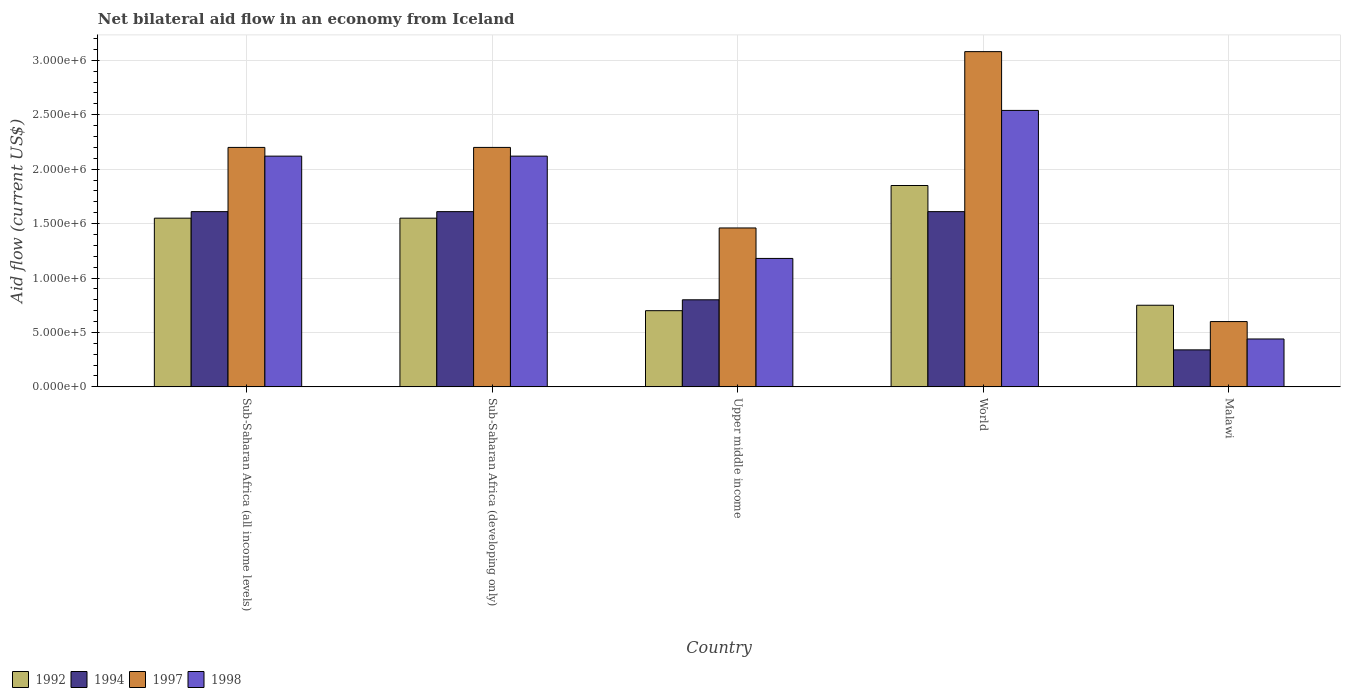How many groups of bars are there?
Provide a succinct answer. 5. Are the number of bars on each tick of the X-axis equal?
Your response must be concise. Yes. What is the label of the 3rd group of bars from the left?
Ensure brevity in your answer.  Upper middle income. What is the net bilateral aid flow in 1994 in Sub-Saharan Africa (developing only)?
Provide a succinct answer. 1.61e+06. Across all countries, what is the maximum net bilateral aid flow in 1997?
Keep it short and to the point. 3.08e+06. In which country was the net bilateral aid flow in 1998 minimum?
Give a very brief answer. Malawi. What is the total net bilateral aid flow in 1994 in the graph?
Your answer should be very brief. 5.97e+06. What is the difference between the net bilateral aid flow in 1994 in Malawi and that in Upper middle income?
Provide a succinct answer. -4.60e+05. What is the difference between the net bilateral aid flow in 1994 in Sub-Saharan Africa (all income levels) and the net bilateral aid flow in 1992 in Upper middle income?
Ensure brevity in your answer.  9.10e+05. What is the average net bilateral aid flow in 1992 per country?
Your answer should be very brief. 1.28e+06. What is the difference between the net bilateral aid flow of/in 1997 and net bilateral aid flow of/in 1994 in Malawi?
Your response must be concise. 2.60e+05. What is the ratio of the net bilateral aid flow in 1998 in Malawi to that in Sub-Saharan Africa (developing only)?
Ensure brevity in your answer.  0.21. What is the difference between the highest and the second highest net bilateral aid flow in 1992?
Provide a short and direct response. 3.00e+05. What is the difference between the highest and the lowest net bilateral aid flow in 1994?
Offer a very short reply. 1.27e+06. In how many countries, is the net bilateral aid flow in 1997 greater than the average net bilateral aid flow in 1997 taken over all countries?
Ensure brevity in your answer.  3. Is the sum of the net bilateral aid flow in 1992 in Malawi and Upper middle income greater than the maximum net bilateral aid flow in 1998 across all countries?
Make the answer very short. No. Is it the case that in every country, the sum of the net bilateral aid flow in 1998 and net bilateral aid flow in 1992 is greater than the sum of net bilateral aid flow in 1994 and net bilateral aid flow in 1997?
Provide a short and direct response. No. What does the 2nd bar from the left in Upper middle income represents?
Ensure brevity in your answer.  1994. How many countries are there in the graph?
Offer a very short reply. 5. Does the graph contain grids?
Ensure brevity in your answer.  Yes. Where does the legend appear in the graph?
Your answer should be compact. Bottom left. How many legend labels are there?
Your response must be concise. 4. What is the title of the graph?
Make the answer very short. Net bilateral aid flow in an economy from Iceland. What is the label or title of the X-axis?
Offer a terse response. Country. What is the Aid flow (current US$) in 1992 in Sub-Saharan Africa (all income levels)?
Your answer should be very brief. 1.55e+06. What is the Aid flow (current US$) in 1994 in Sub-Saharan Africa (all income levels)?
Offer a terse response. 1.61e+06. What is the Aid flow (current US$) in 1997 in Sub-Saharan Africa (all income levels)?
Your answer should be compact. 2.20e+06. What is the Aid flow (current US$) of 1998 in Sub-Saharan Africa (all income levels)?
Provide a succinct answer. 2.12e+06. What is the Aid flow (current US$) of 1992 in Sub-Saharan Africa (developing only)?
Ensure brevity in your answer.  1.55e+06. What is the Aid flow (current US$) in 1994 in Sub-Saharan Africa (developing only)?
Give a very brief answer. 1.61e+06. What is the Aid flow (current US$) of 1997 in Sub-Saharan Africa (developing only)?
Keep it short and to the point. 2.20e+06. What is the Aid flow (current US$) in 1998 in Sub-Saharan Africa (developing only)?
Your response must be concise. 2.12e+06. What is the Aid flow (current US$) in 1992 in Upper middle income?
Offer a terse response. 7.00e+05. What is the Aid flow (current US$) of 1994 in Upper middle income?
Your answer should be very brief. 8.00e+05. What is the Aid flow (current US$) in 1997 in Upper middle income?
Your answer should be very brief. 1.46e+06. What is the Aid flow (current US$) in 1998 in Upper middle income?
Your answer should be very brief. 1.18e+06. What is the Aid flow (current US$) in 1992 in World?
Offer a terse response. 1.85e+06. What is the Aid flow (current US$) of 1994 in World?
Your response must be concise. 1.61e+06. What is the Aid flow (current US$) in 1997 in World?
Give a very brief answer. 3.08e+06. What is the Aid flow (current US$) of 1998 in World?
Ensure brevity in your answer.  2.54e+06. What is the Aid flow (current US$) in 1992 in Malawi?
Keep it short and to the point. 7.50e+05. What is the Aid flow (current US$) of 1998 in Malawi?
Ensure brevity in your answer.  4.40e+05. Across all countries, what is the maximum Aid flow (current US$) of 1992?
Keep it short and to the point. 1.85e+06. Across all countries, what is the maximum Aid flow (current US$) of 1994?
Your answer should be compact. 1.61e+06. Across all countries, what is the maximum Aid flow (current US$) in 1997?
Ensure brevity in your answer.  3.08e+06. Across all countries, what is the maximum Aid flow (current US$) of 1998?
Offer a very short reply. 2.54e+06. Across all countries, what is the minimum Aid flow (current US$) of 1994?
Offer a terse response. 3.40e+05. Across all countries, what is the minimum Aid flow (current US$) in 1998?
Ensure brevity in your answer.  4.40e+05. What is the total Aid flow (current US$) of 1992 in the graph?
Give a very brief answer. 6.40e+06. What is the total Aid flow (current US$) in 1994 in the graph?
Your answer should be very brief. 5.97e+06. What is the total Aid flow (current US$) of 1997 in the graph?
Your answer should be very brief. 9.54e+06. What is the total Aid flow (current US$) of 1998 in the graph?
Provide a succinct answer. 8.40e+06. What is the difference between the Aid flow (current US$) in 1992 in Sub-Saharan Africa (all income levels) and that in Sub-Saharan Africa (developing only)?
Provide a succinct answer. 0. What is the difference between the Aid flow (current US$) of 1992 in Sub-Saharan Africa (all income levels) and that in Upper middle income?
Give a very brief answer. 8.50e+05. What is the difference between the Aid flow (current US$) in 1994 in Sub-Saharan Africa (all income levels) and that in Upper middle income?
Offer a terse response. 8.10e+05. What is the difference between the Aid flow (current US$) in 1997 in Sub-Saharan Africa (all income levels) and that in Upper middle income?
Ensure brevity in your answer.  7.40e+05. What is the difference between the Aid flow (current US$) in 1998 in Sub-Saharan Africa (all income levels) and that in Upper middle income?
Make the answer very short. 9.40e+05. What is the difference between the Aid flow (current US$) in 1992 in Sub-Saharan Africa (all income levels) and that in World?
Provide a short and direct response. -3.00e+05. What is the difference between the Aid flow (current US$) in 1997 in Sub-Saharan Africa (all income levels) and that in World?
Ensure brevity in your answer.  -8.80e+05. What is the difference between the Aid flow (current US$) of 1998 in Sub-Saharan Africa (all income levels) and that in World?
Provide a short and direct response. -4.20e+05. What is the difference between the Aid flow (current US$) of 1994 in Sub-Saharan Africa (all income levels) and that in Malawi?
Provide a succinct answer. 1.27e+06. What is the difference between the Aid flow (current US$) of 1997 in Sub-Saharan Africa (all income levels) and that in Malawi?
Make the answer very short. 1.60e+06. What is the difference between the Aid flow (current US$) of 1998 in Sub-Saharan Africa (all income levels) and that in Malawi?
Offer a very short reply. 1.68e+06. What is the difference between the Aid flow (current US$) of 1992 in Sub-Saharan Africa (developing only) and that in Upper middle income?
Provide a short and direct response. 8.50e+05. What is the difference between the Aid flow (current US$) in 1994 in Sub-Saharan Africa (developing only) and that in Upper middle income?
Provide a short and direct response. 8.10e+05. What is the difference between the Aid flow (current US$) of 1997 in Sub-Saharan Africa (developing only) and that in Upper middle income?
Keep it short and to the point. 7.40e+05. What is the difference between the Aid flow (current US$) of 1998 in Sub-Saharan Africa (developing only) and that in Upper middle income?
Your answer should be very brief. 9.40e+05. What is the difference between the Aid flow (current US$) in 1992 in Sub-Saharan Africa (developing only) and that in World?
Offer a terse response. -3.00e+05. What is the difference between the Aid flow (current US$) of 1997 in Sub-Saharan Africa (developing only) and that in World?
Give a very brief answer. -8.80e+05. What is the difference between the Aid flow (current US$) in 1998 in Sub-Saharan Africa (developing only) and that in World?
Your answer should be very brief. -4.20e+05. What is the difference between the Aid flow (current US$) in 1992 in Sub-Saharan Africa (developing only) and that in Malawi?
Keep it short and to the point. 8.00e+05. What is the difference between the Aid flow (current US$) of 1994 in Sub-Saharan Africa (developing only) and that in Malawi?
Offer a very short reply. 1.27e+06. What is the difference between the Aid flow (current US$) in 1997 in Sub-Saharan Africa (developing only) and that in Malawi?
Ensure brevity in your answer.  1.60e+06. What is the difference between the Aid flow (current US$) of 1998 in Sub-Saharan Africa (developing only) and that in Malawi?
Keep it short and to the point. 1.68e+06. What is the difference between the Aid flow (current US$) of 1992 in Upper middle income and that in World?
Make the answer very short. -1.15e+06. What is the difference between the Aid flow (current US$) of 1994 in Upper middle income and that in World?
Your answer should be very brief. -8.10e+05. What is the difference between the Aid flow (current US$) in 1997 in Upper middle income and that in World?
Your answer should be very brief. -1.62e+06. What is the difference between the Aid flow (current US$) of 1998 in Upper middle income and that in World?
Make the answer very short. -1.36e+06. What is the difference between the Aid flow (current US$) in 1992 in Upper middle income and that in Malawi?
Your answer should be very brief. -5.00e+04. What is the difference between the Aid flow (current US$) of 1997 in Upper middle income and that in Malawi?
Make the answer very short. 8.60e+05. What is the difference between the Aid flow (current US$) of 1998 in Upper middle income and that in Malawi?
Ensure brevity in your answer.  7.40e+05. What is the difference between the Aid flow (current US$) of 1992 in World and that in Malawi?
Ensure brevity in your answer.  1.10e+06. What is the difference between the Aid flow (current US$) in 1994 in World and that in Malawi?
Your answer should be compact. 1.27e+06. What is the difference between the Aid flow (current US$) of 1997 in World and that in Malawi?
Provide a short and direct response. 2.48e+06. What is the difference between the Aid flow (current US$) of 1998 in World and that in Malawi?
Your answer should be very brief. 2.10e+06. What is the difference between the Aid flow (current US$) of 1992 in Sub-Saharan Africa (all income levels) and the Aid flow (current US$) of 1997 in Sub-Saharan Africa (developing only)?
Your answer should be compact. -6.50e+05. What is the difference between the Aid flow (current US$) of 1992 in Sub-Saharan Africa (all income levels) and the Aid flow (current US$) of 1998 in Sub-Saharan Africa (developing only)?
Your answer should be compact. -5.70e+05. What is the difference between the Aid flow (current US$) in 1994 in Sub-Saharan Africa (all income levels) and the Aid flow (current US$) in 1997 in Sub-Saharan Africa (developing only)?
Offer a very short reply. -5.90e+05. What is the difference between the Aid flow (current US$) in 1994 in Sub-Saharan Africa (all income levels) and the Aid flow (current US$) in 1998 in Sub-Saharan Africa (developing only)?
Give a very brief answer. -5.10e+05. What is the difference between the Aid flow (current US$) in 1997 in Sub-Saharan Africa (all income levels) and the Aid flow (current US$) in 1998 in Sub-Saharan Africa (developing only)?
Provide a short and direct response. 8.00e+04. What is the difference between the Aid flow (current US$) in 1992 in Sub-Saharan Africa (all income levels) and the Aid flow (current US$) in 1994 in Upper middle income?
Give a very brief answer. 7.50e+05. What is the difference between the Aid flow (current US$) of 1992 in Sub-Saharan Africa (all income levels) and the Aid flow (current US$) of 1997 in Upper middle income?
Your answer should be compact. 9.00e+04. What is the difference between the Aid flow (current US$) in 1997 in Sub-Saharan Africa (all income levels) and the Aid flow (current US$) in 1998 in Upper middle income?
Make the answer very short. 1.02e+06. What is the difference between the Aid flow (current US$) of 1992 in Sub-Saharan Africa (all income levels) and the Aid flow (current US$) of 1994 in World?
Ensure brevity in your answer.  -6.00e+04. What is the difference between the Aid flow (current US$) in 1992 in Sub-Saharan Africa (all income levels) and the Aid flow (current US$) in 1997 in World?
Offer a terse response. -1.53e+06. What is the difference between the Aid flow (current US$) in 1992 in Sub-Saharan Africa (all income levels) and the Aid flow (current US$) in 1998 in World?
Provide a short and direct response. -9.90e+05. What is the difference between the Aid flow (current US$) in 1994 in Sub-Saharan Africa (all income levels) and the Aid flow (current US$) in 1997 in World?
Make the answer very short. -1.47e+06. What is the difference between the Aid flow (current US$) in 1994 in Sub-Saharan Africa (all income levels) and the Aid flow (current US$) in 1998 in World?
Offer a terse response. -9.30e+05. What is the difference between the Aid flow (current US$) in 1997 in Sub-Saharan Africa (all income levels) and the Aid flow (current US$) in 1998 in World?
Offer a terse response. -3.40e+05. What is the difference between the Aid flow (current US$) in 1992 in Sub-Saharan Africa (all income levels) and the Aid flow (current US$) in 1994 in Malawi?
Offer a terse response. 1.21e+06. What is the difference between the Aid flow (current US$) of 1992 in Sub-Saharan Africa (all income levels) and the Aid flow (current US$) of 1997 in Malawi?
Give a very brief answer. 9.50e+05. What is the difference between the Aid flow (current US$) in 1992 in Sub-Saharan Africa (all income levels) and the Aid flow (current US$) in 1998 in Malawi?
Keep it short and to the point. 1.11e+06. What is the difference between the Aid flow (current US$) in 1994 in Sub-Saharan Africa (all income levels) and the Aid flow (current US$) in 1997 in Malawi?
Give a very brief answer. 1.01e+06. What is the difference between the Aid flow (current US$) in 1994 in Sub-Saharan Africa (all income levels) and the Aid flow (current US$) in 1998 in Malawi?
Offer a very short reply. 1.17e+06. What is the difference between the Aid flow (current US$) in 1997 in Sub-Saharan Africa (all income levels) and the Aid flow (current US$) in 1998 in Malawi?
Provide a short and direct response. 1.76e+06. What is the difference between the Aid flow (current US$) in 1992 in Sub-Saharan Africa (developing only) and the Aid flow (current US$) in 1994 in Upper middle income?
Make the answer very short. 7.50e+05. What is the difference between the Aid flow (current US$) of 1997 in Sub-Saharan Africa (developing only) and the Aid flow (current US$) of 1998 in Upper middle income?
Ensure brevity in your answer.  1.02e+06. What is the difference between the Aid flow (current US$) in 1992 in Sub-Saharan Africa (developing only) and the Aid flow (current US$) in 1994 in World?
Offer a terse response. -6.00e+04. What is the difference between the Aid flow (current US$) of 1992 in Sub-Saharan Africa (developing only) and the Aid flow (current US$) of 1997 in World?
Provide a succinct answer. -1.53e+06. What is the difference between the Aid flow (current US$) of 1992 in Sub-Saharan Africa (developing only) and the Aid flow (current US$) of 1998 in World?
Offer a terse response. -9.90e+05. What is the difference between the Aid flow (current US$) in 1994 in Sub-Saharan Africa (developing only) and the Aid flow (current US$) in 1997 in World?
Your answer should be compact. -1.47e+06. What is the difference between the Aid flow (current US$) in 1994 in Sub-Saharan Africa (developing only) and the Aid flow (current US$) in 1998 in World?
Provide a short and direct response. -9.30e+05. What is the difference between the Aid flow (current US$) in 1997 in Sub-Saharan Africa (developing only) and the Aid flow (current US$) in 1998 in World?
Ensure brevity in your answer.  -3.40e+05. What is the difference between the Aid flow (current US$) in 1992 in Sub-Saharan Africa (developing only) and the Aid flow (current US$) in 1994 in Malawi?
Your answer should be compact. 1.21e+06. What is the difference between the Aid flow (current US$) in 1992 in Sub-Saharan Africa (developing only) and the Aid flow (current US$) in 1997 in Malawi?
Make the answer very short. 9.50e+05. What is the difference between the Aid flow (current US$) in 1992 in Sub-Saharan Africa (developing only) and the Aid flow (current US$) in 1998 in Malawi?
Provide a succinct answer. 1.11e+06. What is the difference between the Aid flow (current US$) of 1994 in Sub-Saharan Africa (developing only) and the Aid flow (current US$) of 1997 in Malawi?
Provide a succinct answer. 1.01e+06. What is the difference between the Aid flow (current US$) of 1994 in Sub-Saharan Africa (developing only) and the Aid flow (current US$) of 1998 in Malawi?
Ensure brevity in your answer.  1.17e+06. What is the difference between the Aid flow (current US$) of 1997 in Sub-Saharan Africa (developing only) and the Aid flow (current US$) of 1998 in Malawi?
Give a very brief answer. 1.76e+06. What is the difference between the Aid flow (current US$) in 1992 in Upper middle income and the Aid flow (current US$) in 1994 in World?
Offer a terse response. -9.10e+05. What is the difference between the Aid flow (current US$) of 1992 in Upper middle income and the Aid flow (current US$) of 1997 in World?
Offer a very short reply. -2.38e+06. What is the difference between the Aid flow (current US$) of 1992 in Upper middle income and the Aid flow (current US$) of 1998 in World?
Offer a very short reply. -1.84e+06. What is the difference between the Aid flow (current US$) of 1994 in Upper middle income and the Aid flow (current US$) of 1997 in World?
Provide a succinct answer. -2.28e+06. What is the difference between the Aid flow (current US$) in 1994 in Upper middle income and the Aid flow (current US$) in 1998 in World?
Offer a very short reply. -1.74e+06. What is the difference between the Aid flow (current US$) of 1997 in Upper middle income and the Aid flow (current US$) of 1998 in World?
Your response must be concise. -1.08e+06. What is the difference between the Aid flow (current US$) in 1992 in Upper middle income and the Aid flow (current US$) in 1997 in Malawi?
Your answer should be very brief. 1.00e+05. What is the difference between the Aid flow (current US$) of 1997 in Upper middle income and the Aid flow (current US$) of 1998 in Malawi?
Your answer should be very brief. 1.02e+06. What is the difference between the Aid flow (current US$) in 1992 in World and the Aid flow (current US$) in 1994 in Malawi?
Provide a short and direct response. 1.51e+06. What is the difference between the Aid flow (current US$) of 1992 in World and the Aid flow (current US$) of 1997 in Malawi?
Your answer should be compact. 1.25e+06. What is the difference between the Aid flow (current US$) in 1992 in World and the Aid flow (current US$) in 1998 in Malawi?
Keep it short and to the point. 1.41e+06. What is the difference between the Aid flow (current US$) of 1994 in World and the Aid flow (current US$) of 1997 in Malawi?
Your response must be concise. 1.01e+06. What is the difference between the Aid flow (current US$) in 1994 in World and the Aid flow (current US$) in 1998 in Malawi?
Provide a short and direct response. 1.17e+06. What is the difference between the Aid flow (current US$) of 1997 in World and the Aid flow (current US$) of 1998 in Malawi?
Your answer should be very brief. 2.64e+06. What is the average Aid flow (current US$) of 1992 per country?
Your answer should be compact. 1.28e+06. What is the average Aid flow (current US$) in 1994 per country?
Offer a very short reply. 1.19e+06. What is the average Aid flow (current US$) in 1997 per country?
Offer a terse response. 1.91e+06. What is the average Aid flow (current US$) of 1998 per country?
Provide a short and direct response. 1.68e+06. What is the difference between the Aid flow (current US$) in 1992 and Aid flow (current US$) in 1997 in Sub-Saharan Africa (all income levels)?
Make the answer very short. -6.50e+05. What is the difference between the Aid flow (current US$) in 1992 and Aid flow (current US$) in 1998 in Sub-Saharan Africa (all income levels)?
Offer a terse response. -5.70e+05. What is the difference between the Aid flow (current US$) of 1994 and Aid flow (current US$) of 1997 in Sub-Saharan Africa (all income levels)?
Offer a very short reply. -5.90e+05. What is the difference between the Aid flow (current US$) in 1994 and Aid flow (current US$) in 1998 in Sub-Saharan Africa (all income levels)?
Offer a very short reply. -5.10e+05. What is the difference between the Aid flow (current US$) of 1992 and Aid flow (current US$) of 1994 in Sub-Saharan Africa (developing only)?
Your response must be concise. -6.00e+04. What is the difference between the Aid flow (current US$) in 1992 and Aid flow (current US$) in 1997 in Sub-Saharan Africa (developing only)?
Your answer should be very brief. -6.50e+05. What is the difference between the Aid flow (current US$) in 1992 and Aid flow (current US$) in 1998 in Sub-Saharan Africa (developing only)?
Keep it short and to the point. -5.70e+05. What is the difference between the Aid flow (current US$) in 1994 and Aid flow (current US$) in 1997 in Sub-Saharan Africa (developing only)?
Ensure brevity in your answer.  -5.90e+05. What is the difference between the Aid flow (current US$) in 1994 and Aid flow (current US$) in 1998 in Sub-Saharan Africa (developing only)?
Provide a succinct answer. -5.10e+05. What is the difference between the Aid flow (current US$) of 1997 and Aid flow (current US$) of 1998 in Sub-Saharan Africa (developing only)?
Provide a short and direct response. 8.00e+04. What is the difference between the Aid flow (current US$) in 1992 and Aid flow (current US$) in 1994 in Upper middle income?
Provide a succinct answer. -1.00e+05. What is the difference between the Aid flow (current US$) of 1992 and Aid flow (current US$) of 1997 in Upper middle income?
Provide a short and direct response. -7.60e+05. What is the difference between the Aid flow (current US$) of 1992 and Aid flow (current US$) of 1998 in Upper middle income?
Offer a terse response. -4.80e+05. What is the difference between the Aid flow (current US$) of 1994 and Aid flow (current US$) of 1997 in Upper middle income?
Provide a short and direct response. -6.60e+05. What is the difference between the Aid flow (current US$) of 1994 and Aid flow (current US$) of 1998 in Upper middle income?
Ensure brevity in your answer.  -3.80e+05. What is the difference between the Aid flow (current US$) in 1992 and Aid flow (current US$) in 1997 in World?
Your answer should be very brief. -1.23e+06. What is the difference between the Aid flow (current US$) of 1992 and Aid flow (current US$) of 1998 in World?
Offer a very short reply. -6.90e+05. What is the difference between the Aid flow (current US$) of 1994 and Aid flow (current US$) of 1997 in World?
Provide a short and direct response. -1.47e+06. What is the difference between the Aid flow (current US$) of 1994 and Aid flow (current US$) of 1998 in World?
Ensure brevity in your answer.  -9.30e+05. What is the difference between the Aid flow (current US$) of 1997 and Aid flow (current US$) of 1998 in World?
Give a very brief answer. 5.40e+05. What is the difference between the Aid flow (current US$) in 1992 and Aid flow (current US$) in 1994 in Malawi?
Ensure brevity in your answer.  4.10e+05. What is the difference between the Aid flow (current US$) in 1992 and Aid flow (current US$) in 1998 in Malawi?
Keep it short and to the point. 3.10e+05. What is the difference between the Aid flow (current US$) of 1994 and Aid flow (current US$) of 1997 in Malawi?
Provide a short and direct response. -2.60e+05. What is the ratio of the Aid flow (current US$) in 1992 in Sub-Saharan Africa (all income levels) to that in Sub-Saharan Africa (developing only)?
Provide a succinct answer. 1. What is the ratio of the Aid flow (current US$) of 1994 in Sub-Saharan Africa (all income levels) to that in Sub-Saharan Africa (developing only)?
Ensure brevity in your answer.  1. What is the ratio of the Aid flow (current US$) in 1998 in Sub-Saharan Africa (all income levels) to that in Sub-Saharan Africa (developing only)?
Provide a short and direct response. 1. What is the ratio of the Aid flow (current US$) in 1992 in Sub-Saharan Africa (all income levels) to that in Upper middle income?
Offer a terse response. 2.21. What is the ratio of the Aid flow (current US$) in 1994 in Sub-Saharan Africa (all income levels) to that in Upper middle income?
Your answer should be compact. 2.01. What is the ratio of the Aid flow (current US$) in 1997 in Sub-Saharan Africa (all income levels) to that in Upper middle income?
Your answer should be compact. 1.51. What is the ratio of the Aid flow (current US$) in 1998 in Sub-Saharan Africa (all income levels) to that in Upper middle income?
Your response must be concise. 1.8. What is the ratio of the Aid flow (current US$) in 1992 in Sub-Saharan Africa (all income levels) to that in World?
Provide a succinct answer. 0.84. What is the ratio of the Aid flow (current US$) in 1994 in Sub-Saharan Africa (all income levels) to that in World?
Offer a terse response. 1. What is the ratio of the Aid flow (current US$) in 1997 in Sub-Saharan Africa (all income levels) to that in World?
Your answer should be compact. 0.71. What is the ratio of the Aid flow (current US$) in 1998 in Sub-Saharan Africa (all income levels) to that in World?
Make the answer very short. 0.83. What is the ratio of the Aid flow (current US$) in 1992 in Sub-Saharan Africa (all income levels) to that in Malawi?
Your answer should be very brief. 2.07. What is the ratio of the Aid flow (current US$) in 1994 in Sub-Saharan Africa (all income levels) to that in Malawi?
Offer a very short reply. 4.74. What is the ratio of the Aid flow (current US$) of 1997 in Sub-Saharan Africa (all income levels) to that in Malawi?
Ensure brevity in your answer.  3.67. What is the ratio of the Aid flow (current US$) in 1998 in Sub-Saharan Africa (all income levels) to that in Malawi?
Your answer should be compact. 4.82. What is the ratio of the Aid flow (current US$) in 1992 in Sub-Saharan Africa (developing only) to that in Upper middle income?
Offer a terse response. 2.21. What is the ratio of the Aid flow (current US$) of 1994 in Sub-Saharan Africa (developing only) to that in Upper middle income?
Make the answer very short. 2.01. What is the ratio of the Aid flow (current US$) in 1997 in Sub-Saharan Africa (developing only) to that in Upper middle income?
Offer a terse response. 1.51. What is the ratio of the Aid flow (current US$) in 1998 in Sub-Saharan Africa (developing only) to that in Upper middle income?
Give a very brief answer. 1.8. What is the ratio of the Aid flow (current US$) of 1992 in Sub-Saharan Africa (developing only) to that in World?
Make the answer very short. 0.84. What is the ratio of the Aid flow (current US$) of 1998 in Sub-Saharan Africa (developing only) to that in World?
Provide a succinct answer. 0.83. What is the ratio of the Aid flow (current US$) in 1992 in Sub-Saharan Africa (developing only) to that in Malawi?
Your response must be concise. 2.07. What is the ratio of the Aid flow (current US$) of 1994 in Sub-Saharan Africa (developing only) to that in Malawi?
Offer a terse response. 4.74. What is the ratio of the Aid flow (current US$) of 1997 in Sub-Saharan Africa (developing only) to that in Malawi?
Your answer should be compact. 3.67. What is the ratio of the Aid flow (current US$) of 1998 in Sub-Saharan Africa (developing only) to that in Malawi?
Keep it short and to the point. 4.82. What is the ratio of the Aid flow (current US$) of 1992 in Upper middle income to that in World?
Give a very brief answer. 0.38. What is the ratio of the Aid flow (current US$) in 1994 in Upper middle income to that in World?
Offer a very short reply. 0.5. What is the ratio of the Aid flow (current US$) in 1997 in Upper middle income to that in World?
Offer a very short reply. 0.47. What is the ratio of the Aid flow (current US$) of 1998 in Upper middle income to that in World?
Provide a short and direct response. 0.46. What is the ratio of the Aid flow (current US$) of 1992 in Upper middle income to that in Malawi?
Your response must be concise. 0.93. What is the ratio of the Aid flow (current US$) in 1994 in Upper middle income to that in Malawi?
Your answer should be compact. 2.35. What is the ratio of the Aid flow (current US$) in 1997 in Upper middle income to that in Malawi?
Ensure brevity in your answer.  2.43. What is the ratio of the Aid flow (current US$) in 1998 in Upper middle income to that in Malawi?
Give a very brief answer. 2.68. What is the ratio of the Aid flow (current US$) of 1992 in World to that in Malawi?
Keep it short and to the point. 2.47. What is the ratio of the Aid flow (current US$) of 1994 in World to that in Malawi?
Offer a terse response. 4.74. What is the ratio of the Aid flow (current US$) of 1997 in World to that in Malawi?
Provide a succinct answer. 5.13. What is the ratio of the Aid flow (current US$) in 1998 in World to that in Malawi?
Give a very brief answer. 5.77. What is the difference between the highest and the second highest Aid flow (current US$) of 1992?
Offer a terse response. 3.00e+05. What is the difference between the highest and the second highest Aid flow (current US$) in 1994?
Your answer should be very brief. 0. What is the difference between the highest and the second highest Aid flow (current US$) in 1997?
Offer a very short reply. 8.80e+05. What is the difference between the highest and the second highest Aid flow (current US$) of 1998?
Your response must be concise. 4.20e+05. What is the difference between the highest and the lowest Aid flow (current US$) in 1992?
Offer a terse response. 1.15e+06. What is the difference between the highest and the lowest Aid flow (current US$) in 1994?
Ensure brevity in your answer.  1.27e+06. What is the difference between the highest and the lowest Aid flow (current US$) of 1997?
Your answer should be compact. 2.48e+06. What is the difference between the highest and the lowest Aid flow (current US$) of 1998?
Your answer should be very brief. 2.10e+06. 